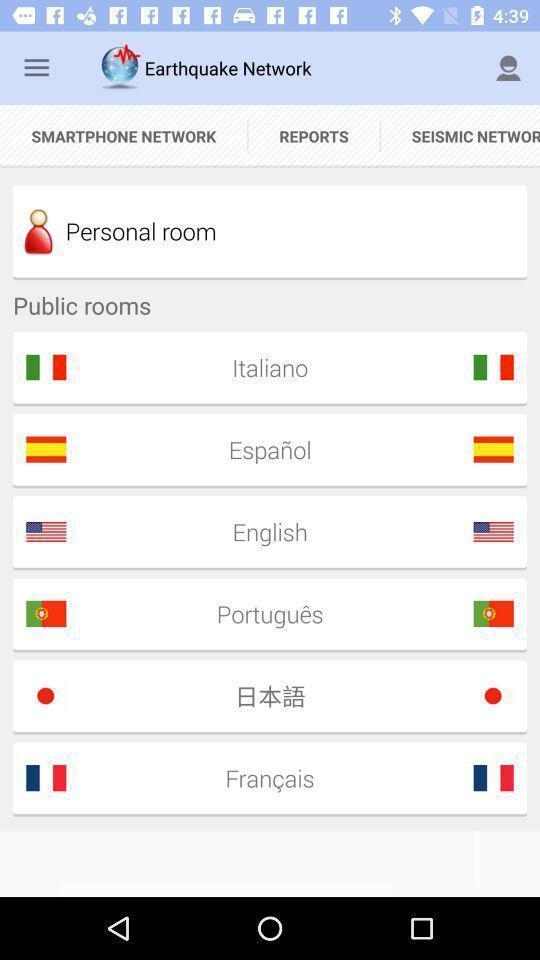Summarize the information in this screenshot. Page showing reports of earthquake network. 